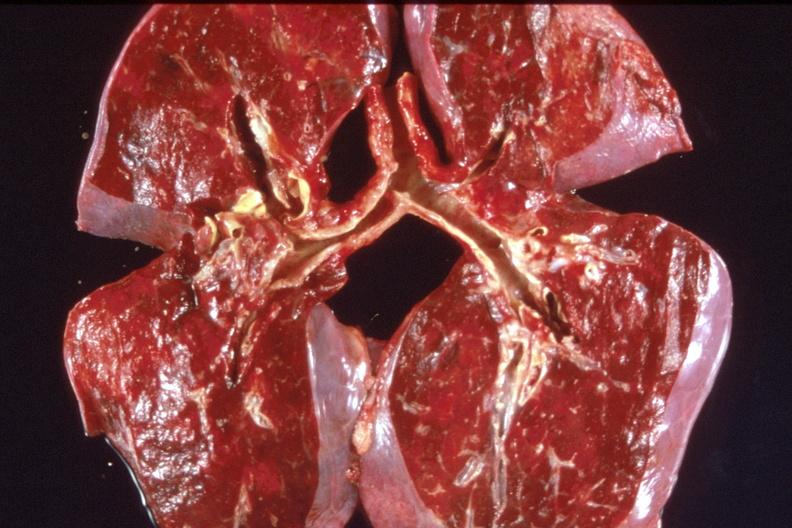does cut surface typical ivory vertebra do not have history at this time diagnosis show lung, pulmonary fibrosis and congestion?
Answer the question using a single word or phrase. No 